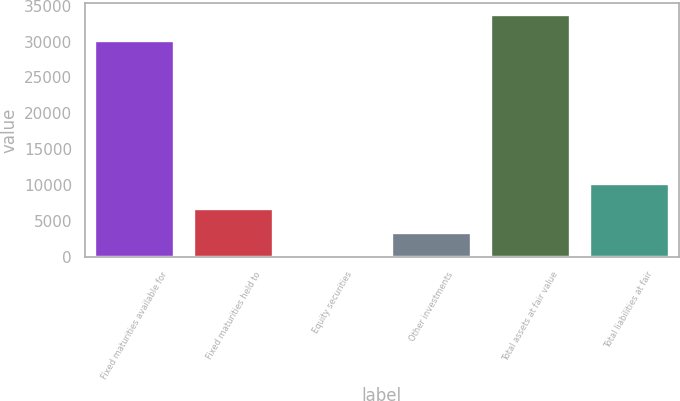<chart> <loc_0><loc_0><loc_500><loc_500><bar_chart><fcel>Fixed maturities available for<fcel>Fixed maturities held to<fcel>Equity securities<fcel>Other investments<fcel>Total assets at fair value<fcel>Total liabilities at fair<nl><fcel>30009<fcel>6750.8<fcel>5<fcel>3377.9<fcel>33734<fcel>10123.7<nl></chart> 